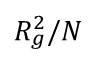<formula> <loc_0><loc_0><loc_500><loc_500>R _ { g } ^ { 2 } / N</formula> 